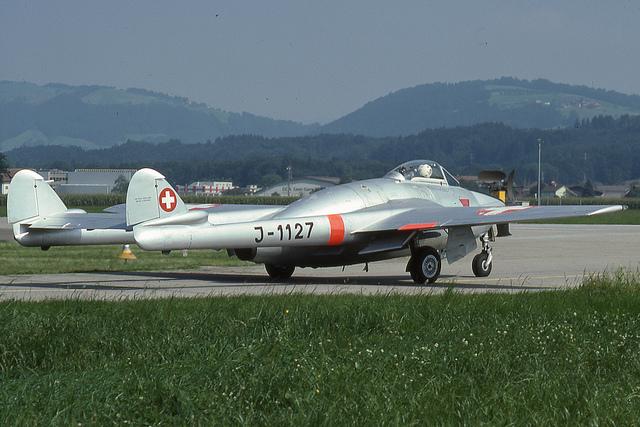Is this some sort of Military aircraft?
Write a very short answer. Yes. What symbol is on the plane's tail?
Be succinct. Cross. IS it on the runway?
Give a very brief answer. Yes. 